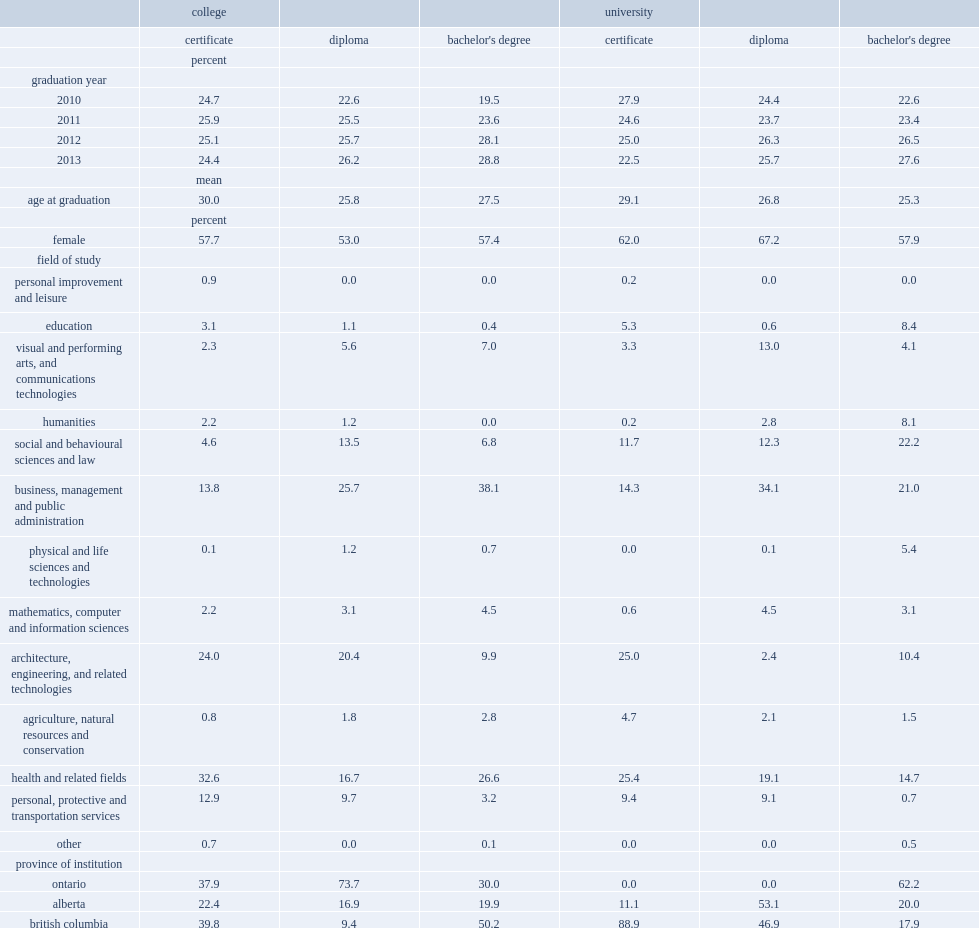Which type of holders are far more likely to have taken programs typically associated with relatively high pay, such as business, management and public administration or health and related fields, cbd holders or ubd holders? Bachelor's degree. Which type of holders are less likely to have taken programs typically associated with relatively low pay, such as education, humanities or social and behavioural sciences and law, cbd holders or ubd holders? Bachelor's degree. Can you parse all the data within this table? {'header': ['', 'college', '', '', 'university', '', ''], 'rows': [['', 'certificate', 'diploma', "bachelor's degree", 'certificate', 'diploma', "bachelor's degree"], ['', 'percent', '', '', '', '', ''], ['graduation year', '', '', '', '', '', ''], ['2010', '24.7', '22.6', '19.5', '27.9', '24.4', '22.6'], ['2011', '25.9', '25.5', '23.6', '24.6', '23.7', '23.4'], ['2012', '25.1', '25.7', '28.1', '25.0', '26.3', '26.5'], ['2013', '24.4', '26.2', '28.8', '22.5', '25.7', '27.6'], ['', 'mean', '', '', '', '', ''], ['age at graduation', '30.0', '25.8', '27.5', '29.1', '26.8', '25.3'], ['', 'percent', '', '', '', '', ''], ['female', '57.7', '53.0', '57.4', '62.0', '67.2', '57.9'], ['field of study', '', '', '', '', '', ''], ['personal improvement and leisure', '0.9', '0.0', '0.0', '0.2', '0.0', '0.0'], ['education', '3.1', '1.1', '0.4', '5.3', '0.6', '8.4'], ['visual and performing arts, and communications technologies', '2.3', '5.6', '7.0', '3.3', '13.0', '4.1'], ['humanities', '2.2', '1.2', '0.0', '0.2', '2.8', '8.1'], ['social and behavioural sciences and law', '4.6', '13.5', '6.8', '11.7', '12.3', '22.2'], ['business, management and public administration', '13.8', '25.7', '38.1', '14.3', '34.1', '21.0'], ['physical and life sciences and technologies', '0.1', '1.2', '0.7', '0.0', '0.1', '5.4'], ['mathematics, computer and information sciences', '2.2', '3.1', '4.5', '0.6', '4.5', '3.1'], ['architecture, engineering, and related technologies', '24.0', '20.4', '9.9', '25.0', '2.4', '10.4'], ['agriculture, natural resources and conservation', '0.8', '1.8', '2.8', '4.7', '2.1', '1.5'], ['health and related fields', '32.6', '16.7', '26.6', '25.4', '19.1', '14.7'], ['personal, protective and transportation services', '12.9', '9.7', '3.2', '9.4', '9.1', '0.7'], ['other', '0.7', '0.0', '0.1', '0.0', '0.0', '0.5'], ['province of institution', '', '', '', '', '', ''], ['ontario', '37.9', '73.7', '30.0', '0.0', '0.0', '62.2'], ['alberta', '22.4', '16.9', '19.9', '11.1', '53.1', '20.0'], ['british columbia', '39.8', '9.4', '50.2', '88.9', '46.9', '17.9']]} 